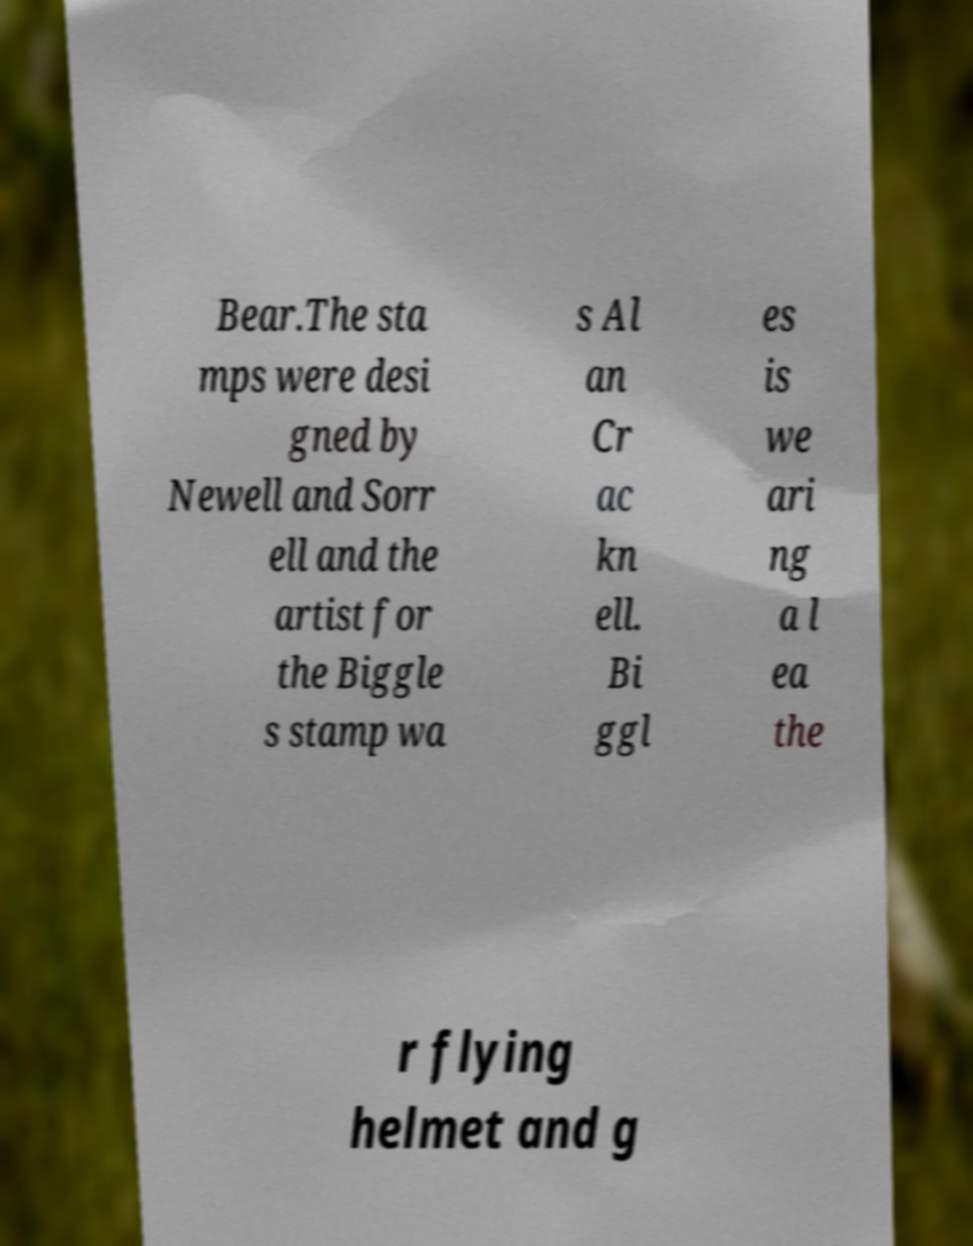Please read and relay the text visible in this image. What does it say? Bear.The sta mps were desi gned by Newell and Sorr ell and the artist for the Biggle s stamp wa s Al an Cr ac kn ell. Bi ggl es is we ari ng a l ea the r flying helmet and g 